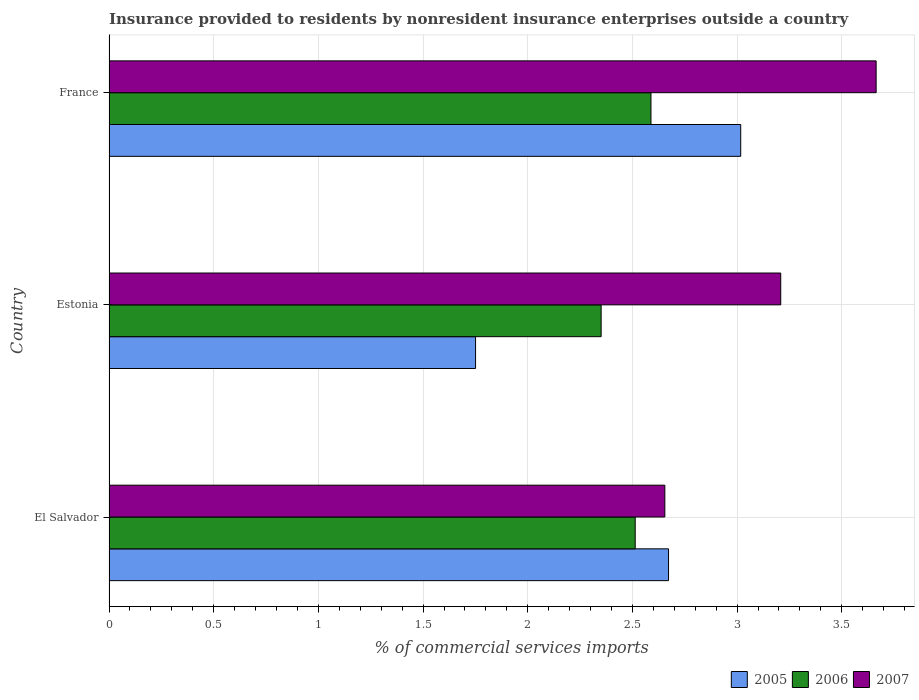How many different coloured bars are there?
Make the answer very short. 3. How many groups of bars are there?
Provide a short and direct response. 3. Are the number of bars on each tick of the Y-axis equal?
Ensure brevity in your answer.  Yes. How many bars are there on the 1st tick from the top?
Keep it short and to the point. 3. What is the label of the 2nd group of bars from the top?
Your answer should be very brief. Estonia. What is the Insurance provided to residents in 2006 in France?
Your answer should be very brief. 2.59. Across all countries, what is the maximum Insurance provided to residents in 2005?
Make the answer very short. 3.02. Across all countries, what is the minimum Insurance provided to residents in 2005?
Your answer should be compact. 1.75. In which country was the Insurance provided to residents in 2005 minimum?
Your answer should be very brief. Estonia. What is the total Insurance provided to residents in 2005 in the graph?
Ensure brevity in your answer.  7.44. What is the difference between the Insurance provided to residents in 2005 in El Salvador and that in Estonia?
Give a very brief answer. 0.92. What is the difference between the Insurance provided to residents in 2007 in El Salvador and the Insurance provided to residents in 2006 in France?
Your response must be concise. 0.07. What is the average Insurance provided to residents in 2007 per country?
Offer a terse response. 3.18. What is the difference between the Insurance provided to residents in 2007 and Insurance provided to residents in 2006 in France?
Your answer should be compact. 1.08. In how many countries, is the Insurance provided to residents in 2007 greater than 3.7 %?
Provide a succinct answer. 0. What is the ratio of the Insurance provided to residents in 2007 in Estonia to that in France?
Ensure brevity in your answer.  0.88. Is the difference between the Insurance provided to residents in 2007 in Estonia and France greater than the difference between the Insurance provided to residents in 2006 in Estonia and France?
Your answer should be very brief. No. What is the difference between the highest and the second highest Insurance provided to residents in 2005?
Give a very brief answer. 0.34. What is the difference between the highest and the lowest Insurance provided to residents in 2005?
Offer a terse response. 1.27. What does the 2nd bar from the top in France represents?
Keep it short and to the point. 2006. Is it the case that in every country, the sum of the Insurance provided to residents in 2006 and Insurance provided to residents in 2007 is greater than the Insurance provided to residents in 2005?
Make the answer very short. Yes. How many bars are there?
Give a very brief answer. 9. Are all the bars in the graph horizontal?
Your response must be concise. Yes. What is the difference between two consecutive major ticks on the X-axis?
Offer a terse response. 0.5. Are the values on the major ticks of X-axis written in scientific E-notation?
Your answer should be very brief. No. Does the graph contain any zero values?
Provide a short and direct response. No. Does the graph contain grids?
Make the answer very short. Yes. Where does the legend appear in the graph?
Provide a short and direct response. Bottom right. What is the title of the graph?
Your answer should be very brief. Insurance provided to residents by nonresident insurance enterprises outside a country. What is the label or title of the X-axis?
Keep it short and to the point. % of commercial services imports. What is the % of commercial services imports in 2005 in El Salvador?
Keep it short and to the point. 2.67. What is the % of commercial services imports in 2006 in El Salvador?
Keep it short and to the point. 2.51. What is the % of commercial services imports of 2007 in El Salvador?
Provide a short and direct response. 2.65. What is the % of commercial services imports of 2005 in Estonia?
Provide a short and direct response. 1.75. What is the % of commercial services imports in 2006 in Estonia?
Keep it short and to the point. 2.35. What is the % of commercial services imports in 2007 in Estonia?
Offer a very short reply. 3.21. What is the % of commercial services imports in 2005 in France?
Ensure brevity in your answer.  3.02. What is the % of commercial services imports in 2006 in France?
Give a very brief answer. 2.59. What is the % of commercial services imports in 2007 in France?
Provide a succinct answer. 3.66. Across all countries, what is the maximum % of commercial services imports in 2005?
Offer a terse response. 3.02. Across all countries, what is the maximum % of commercial services imports of 2006?
Ensure brevity in your answer.  2.59. Across all countries, what is the maximum % of commercial services imports of 2007?
Give a very brief answer. 3.66. Across all countries, what is the minimum % of commercial services imports in 2005?
Your answer should be compact. 1.75. Across all countries, what is the minimum % of commercial services imports of 2006?
Your response must be concise. 2.35. Across all countries, what is the minimum % of commercial services imports of 2007?
Provide a short and direct response. 2.65. What is the total % of commercial services imports of 2005 in the graph?
Your answer should be compact. 7.44. What is the total % of commercial services imports in 2006 in the graph?
Offer a very short reply. 7.45. What is the total % of commercial services imports in 2007 in the graph?
Offer a terse response. 9.53. What is the difference between the % of commercial services imports of 2005 in El Salvador and that in Estonia?
Provide a succinct answer. 0.92. What is the difference between the % of commercial services imports of 2006 in El Salvador and that in Estonia?
Keep it short and to the point. 0.16. What is the difference between the % of commercial services imports in 2007 in El Salvador and that in Estonia?
Your answer should be compact. -0.55. What is the difference between the % of commercial services imports in 2005 in El Salvador and that in France?
Ensure brevity in your answer.  -0.34. What is the difference between the % of commercial services imports of 2006 in El Salvador and that in France?
Ensure brevity in your answer.  -0.08. What is the difference between the % of commercial services imports in 2007 in El Salvador and that in France?
Offer a very short reply. -1.01. What is the difference between the % of commercial services imports in 2005 in Estonia and that in France?
Your answer should be compact. -1.27. What is the difference between the % of commercial services imports in 2006 in Estonia and that in France?
Give a very brief answer. -0.24. What is the difference between the % of commercial services imports in 2007 in Estonia and that in France?
Your response must be concise. -0.46. What is the difference between the % of commercial services imports in 2005 in El Salvador and the % of commercial services imports in 2006 in Estonia?
Offer a very short reply. 0.32. What is the difference between the % of commercial services imports of 2005 in El Salvador and the % of commercial services imports of 2007 in Estonia?
Provide a succinct answer. -0.54. What is the difference between the % of commercial services imports of 2006 in El Salvador and the % of commercial services imports of 2007 in Estonia?
Provide a succinct answer. -0.7. What is the difference between the % of commercial services imports of 2005 in El Salvador and the % of commercial services imports of 2006 in France?
Your answer should be compact. 0.08. What is the difference between the % of commercial services imports of 2005 in El Salvador and the % of commercial services imports of 2007 in France?
Offer a very short reply. -0.99. What is the difference between the % of commercial services imports in 2006 in El Salvador and the % of commercial services imports in 2007 in France?
Provide a short and direct response. -1.15. What is the difference between the % of commercial services imports in 2005 in Estonia and the % of commercial services imports in 2006 in France?
Your response must be concise. -0.84. What is the difference between the % of commercial services imports in 2005 in Estonia and the % of commercial services imports in 2007 in France?
Offer a very short reply. -1.91. What is the difference between the % of commercial services imports in 2006 in Estonia and the % of commercial services imports in 2007 in France?
Your answer should be compact. -1.31. What is the average % of commercial services imports in 2005 per country?
Provide a succinct answer. 2.48. What is the average % of commercial services imports of 2006 per country?
Your response must be concise. 2.48. What is the average % of commercial services imports in 2007 per country?
Make the answer very short. 3.18. What is the difference between the % of commercial services imports of 2005 and % of commercial services imports of 2006 in El Salvador?
Make the answer very short. 0.16. What is the difference between the % of commercial services imports of 2005 and % of commercial services imports of 2007 in El Salvador?
Keep it short and to the point. 0.02. What is the difference between the % of commercial services imports of 2006 and % of commercial services imports of 2007 in El Salvador?
Offer a very short reply. -0.14. What is the difference between the % of commercial services imports in 2005 and % of commercial services imports in 2006 in Estonia?
Provide a short and direct response. -0.6. What is the difference between the % of commercial services imports in 2005 and % of commercial services imports in 2007 in Estonia?
Make the answer very short. -1.46. What is the difference between the % of commercial services imports in 2006 and % of commercial services imports in 2007 in Estonia?
Make the answer very short. -0.86. What is the difference between the % of commercial services imports of 2005 and % of commercial services imports of 2006 in France?
Make the answer very short. 0.43. What is the difference between the % of commercial services imports in 2005 and % of commercial services imports in 2007 in France?
Ensure brevity in your answer.  -0.65. What is the difference between the % of commercial services imports of 2006 and % of commercial services imports of 2007 in France?
Your answer should be compact. -1.08. What is the ratio of the % of commercial services imports in 2005 in El Salvador to that in Estonia?
Your response must be concise. 1.53. What is the ratio of the % of commercial services imports in 2006 in El Salvador to that in Estonia?
Offer a terse response. 1.07. What is the ratio of the % of commercial services imports of 2007 in El Salvador to that in Estonia?
Your answer should be very brief. 0.83. What is the ratio of the % of commercial services imports of 2005 in El Salvador to that in France?
Offer a very short reply. 0.89. What is the ratio of the % of commercial services imports of 2006 in El Salvador to that in France?
Offer a very short reply. 0.97. What is the ratio of the % of commercial services imports in 2007 in El Salvador to that in France?
Your response must be concise. 0.72. What is the ratio of the % of commercial services imports in 2005 in Estonia to that in France?
Provide a short and direct response. 0.58. What is the ratio of the % of commercial services imports of 2006 in Estonia to that in France?
Make the answer very short. 0.91. What is the ratio of the % of commercial services imports of 2007 in Estonia to that in France?
Keep it short and to the point. 0.88. What is the difference between the highest and the second highest % of commercial services imports of 2005?
Your answer should be compact. 0.34. What is the difference between the highest and the second highest % of commercial services imports in 2006?
Your answer should be compact. 0.08. What is the difference between the highest and the second highest % of commercial services imports of 2007?
Offer a very short reply. 0.46. What is the difference between the highest and the lowest % of commercial services imports of 2005?
Provide a succinct answer. 1.27. What is the difference between the highest and the lowest % of commercial services imports in 2006?
Offer a terse response. 0.24. What is the difference between the highest and the lowest % of commercial services imports of 2007?
Provide a succinct answer. 1.01. 